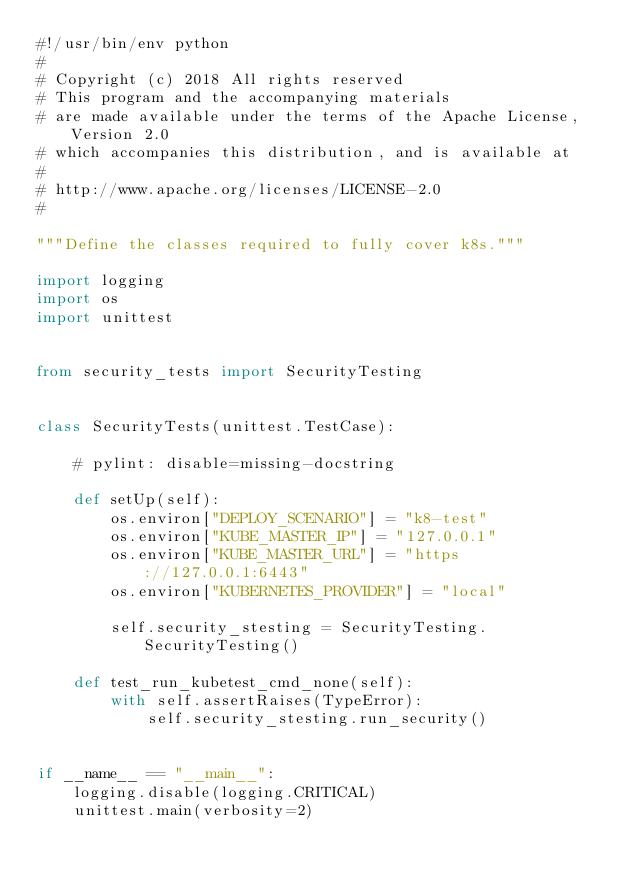Convert code to text. <code><loc_0><loc_0><loc_500><loc_500><_Python_>#!/usr/bin/env python
#
# Copyright (c) 2018 All rights reserved
# This program and the accompanying materials
# are made available under the terms of the Apache License, Version 2.0
# which accompanies this distribution, and is available at
#
# http://www.apache.org/licenses/LICENSE-2.0
#

"""Define the classes required to fully cover k8s."""

import logging
import os
import unittest


from security_tests import SecurityTesting


class SecurityTests(unittest.TestCase):

    # pylint: disable=missing-docstring

    def setUp(self):
        os.environ["DEPLOY_SCENARIO"] = "k8-test"
        os.environ["KUBE_MASTER_IP"] = "127.0.0.1"
        os.environ["KUBE_MASTER_URL"] = "https://127.0.0.1:6443"
        os.environ["KUBERNETES_PROVIDER"] = "local"

        self.security_stesting = SecurityTesting.SecurityTesting()

    def test_run_kubetest_cmd_none(self):
        with self.assertRaises(TypeError):
            self.security_stesting.run_security()


if __name__ == "__main__":
    logging.disable(logging.CRITICAL)
    unittest.main(verbosity=2)
</code> 